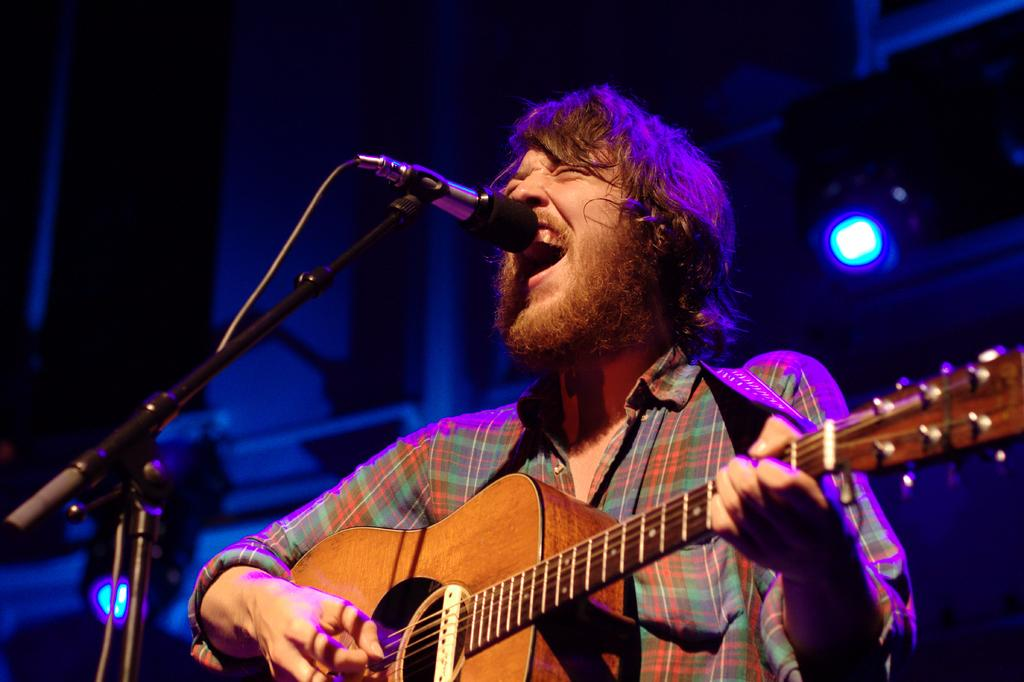What is the main subject of the image? There is a person in the image. What is the person doing in the image? The person is standing in front of a mic. What object is the person holding in the image? The person is holding a guitar. What type of beef is being served at the event in the image? There is no event or beef present in the image; it features a person standing in front of a mic and holding a guitar. How many fingers does the person have on their left hand in the image? The number of fingers on the person's left hand cannot be determined from the image, as their hand is not visible. 